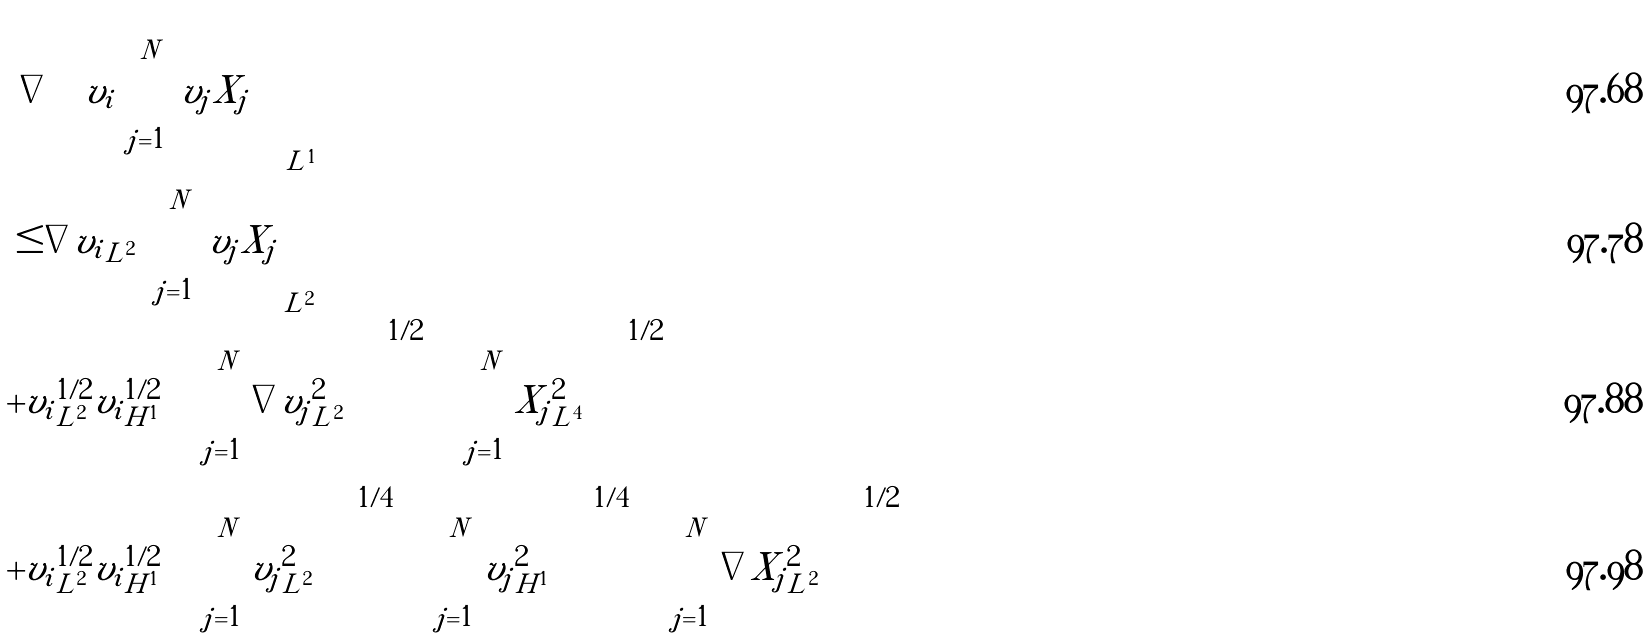<formula> <loc_0><loc_0><loc_500><loc_500>& \left \| \nabla \left ( v _ { i } \sum _ { j = 1 } ^ { N } v _ { j } X _ { j } \right ) \right \| _ { L ^ { 1 } } \\ & \leq \| \nabla v _ { i } \| _ { L ^ { 2 } } \left \| \sum _ { j = 1 } ^ { N } v _ { j } X _ { j } \right \| _ { L ^ { 2 } } \\ & + \| v _ { i } \| _ { L ^ { 2 } } ^ { 1 / 2 } \| v _ { i } \| _ { H ^ { 1 } } ^ { 1 / 2 } \left ( \sum _ { j = 1 } ^ { N } \| \nabla v _ { j } \| _ { L ^ { 2 } } ^ { 2 } \right ) ^ { 1 / 2 } \left ( \sum _ { j = 1 } ^ { N } \| X _ { j } \| _ { L ^ { 4 } } ^ { 2 } \right ) ^ { 1 / 2 } \\ & + \| v _ { i } \| _ { L ^ { 2 } } ^ { 1 / 2 } \| v _ { i } \| _ { H ^ { 1 } } ^ { 1 / 2 } \left ( \sum _ { j = 1 } ^ { N } \| v _ { j } \| _ { L ^ { 2 } } ^ { 2 } \right ) ^ { 1 / 4 } \left ( \sum _ { j = 1 } ^ { N } \| v _ { j } \| _ { H ^ { 1 } } ^ { 2 } \right ) ^ { 1 / 4 } \left ( \sum _ { j = 1 } ^ { N } \| \nabla X _ { j } \| _ { L ^ { 2 } } ^ { 2 } \right ) ^ { 1 / 2 }</formula> 